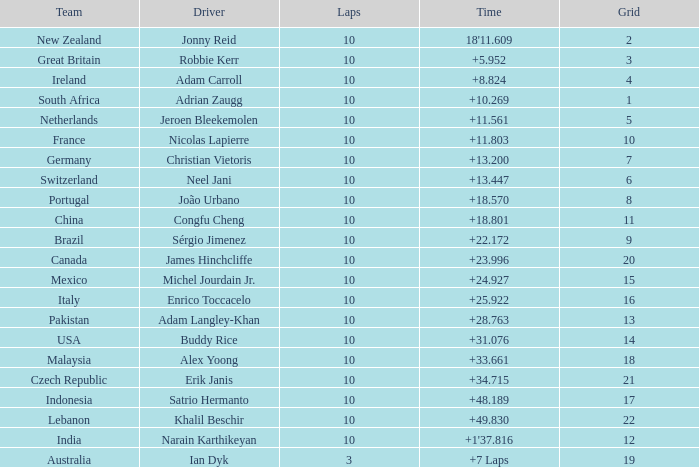For what Team is Narain Karthikeyan the Driver? India. 